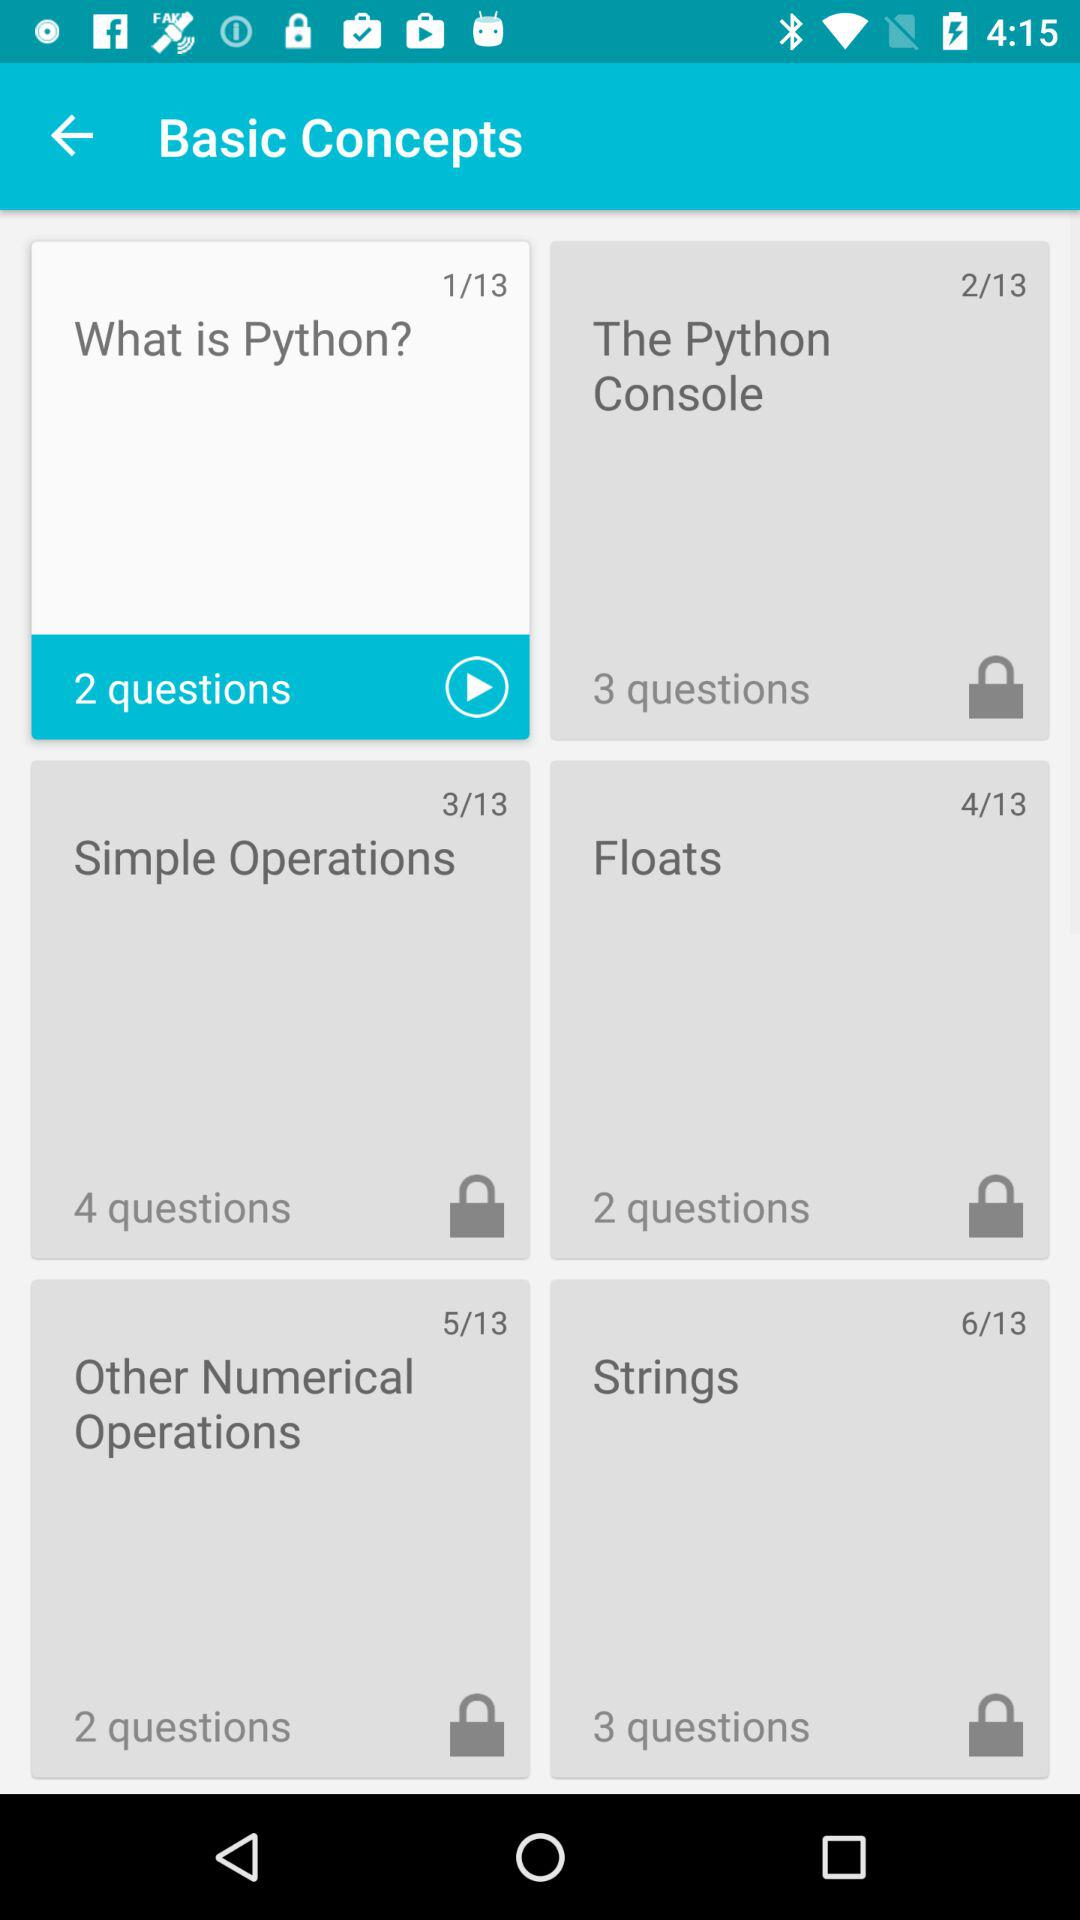What is the number of questions in the "Floats" slide? The number of questions is 2. 